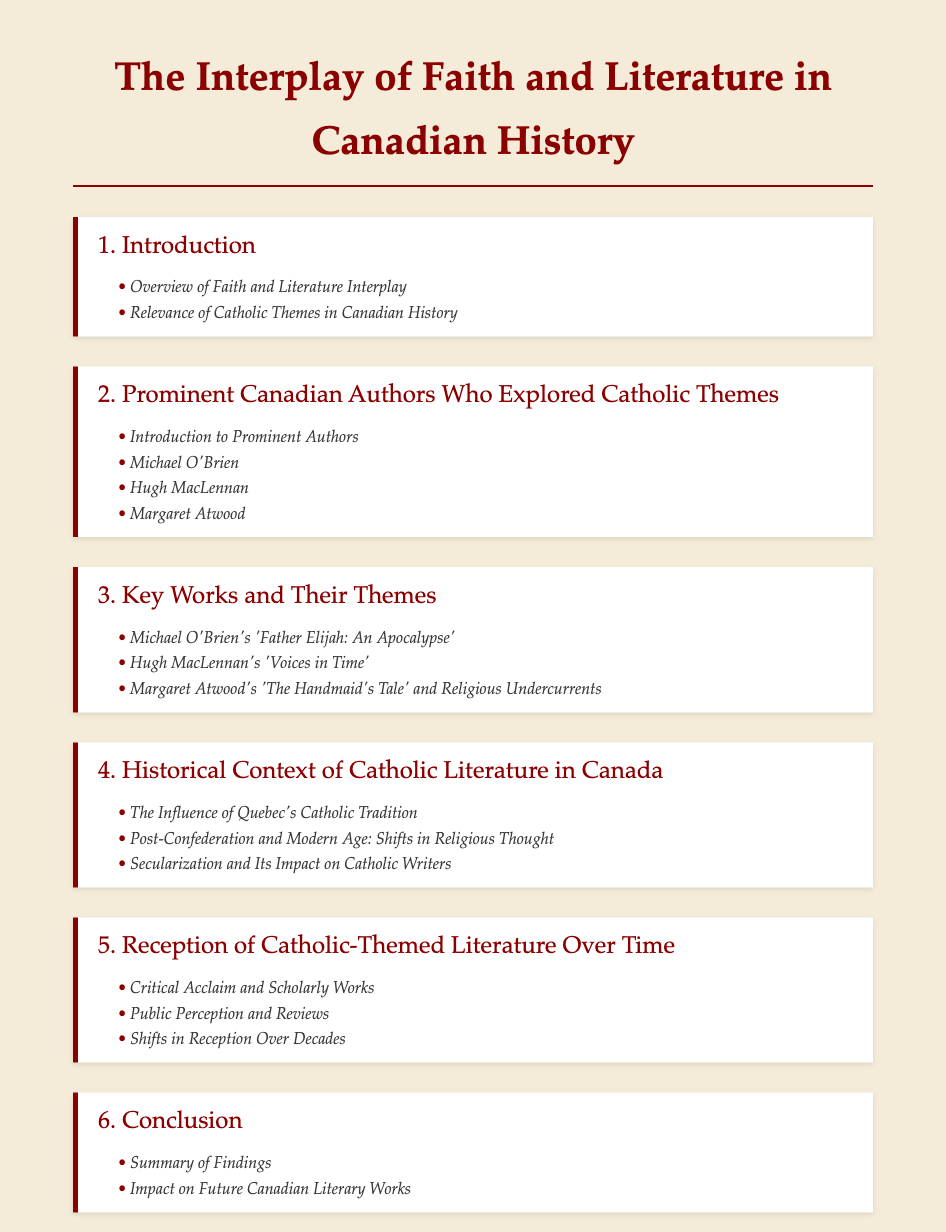What is the title of the document? The title is presented prominently at the top of the document as the main heading.
Answer: The Interplay of Faith and Literature in Canadian History Who is one prominent author explored in this document? The document lists several notable authors in relation to Catholic themes.
Answer: Michael O'Brien What is the title of Michael O'Brien's key work mentioned? A specific work of Michael O'Brien is highlighted in the key works chapter.
Answer: Father Elijah: An Apocalypse What is one subchapter under the conclusion section? The conclusion section offers summaries and implications of the findings discussed in earlier chapters.
Answer: Summary of Findings What significant theme is discussed in Margaret Atwood's work? The document indicates that specific themes are analyzed in connection to her writings.
Answer: Religious Undercurrents How many main chapters are included in the document? The document structure specifies the number of chapters presented.
Answer: Six 